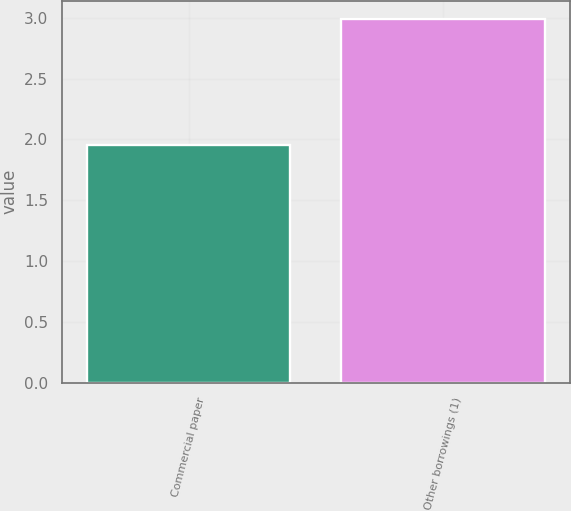<chart> <loc_0><loc_0><loc_500><loc_500><bar_chart><fcel>Commercial paper<fcel>Other borrowings (1)<nl><fcel>1.95<fcel>2.99<nl></chart> 